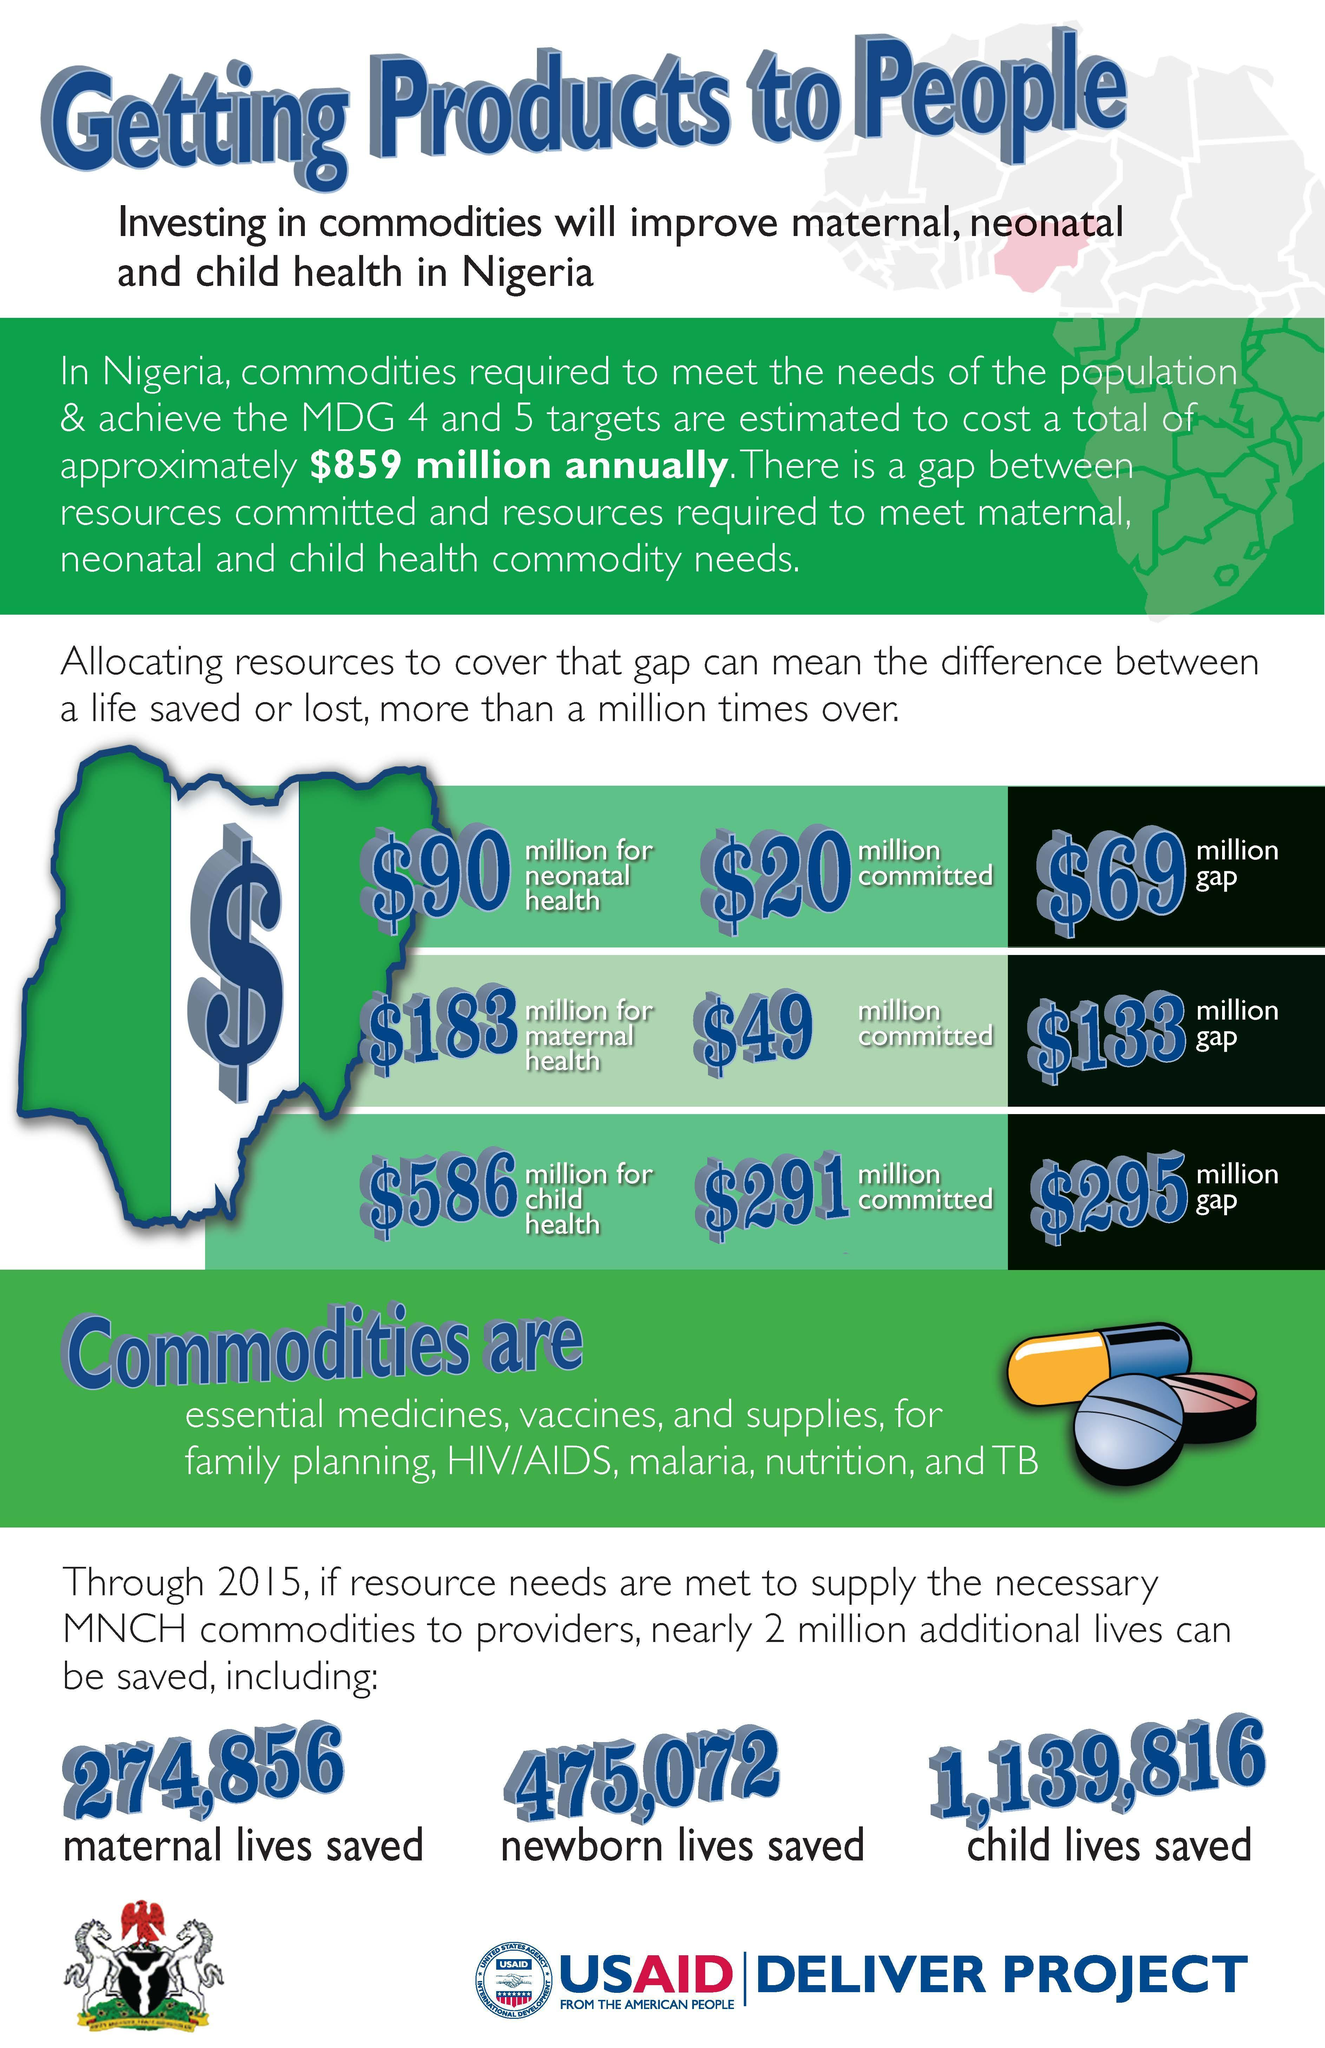What is the total resources committed towards, neonatal, maternal, and child health commodities?
Answer the question with a short phrase. $ 360 million What is the total gap in achieving the health commodity needs? $ 497 million What are total resources required for neonatal, maternal, and child health commodities? $ 859 million 